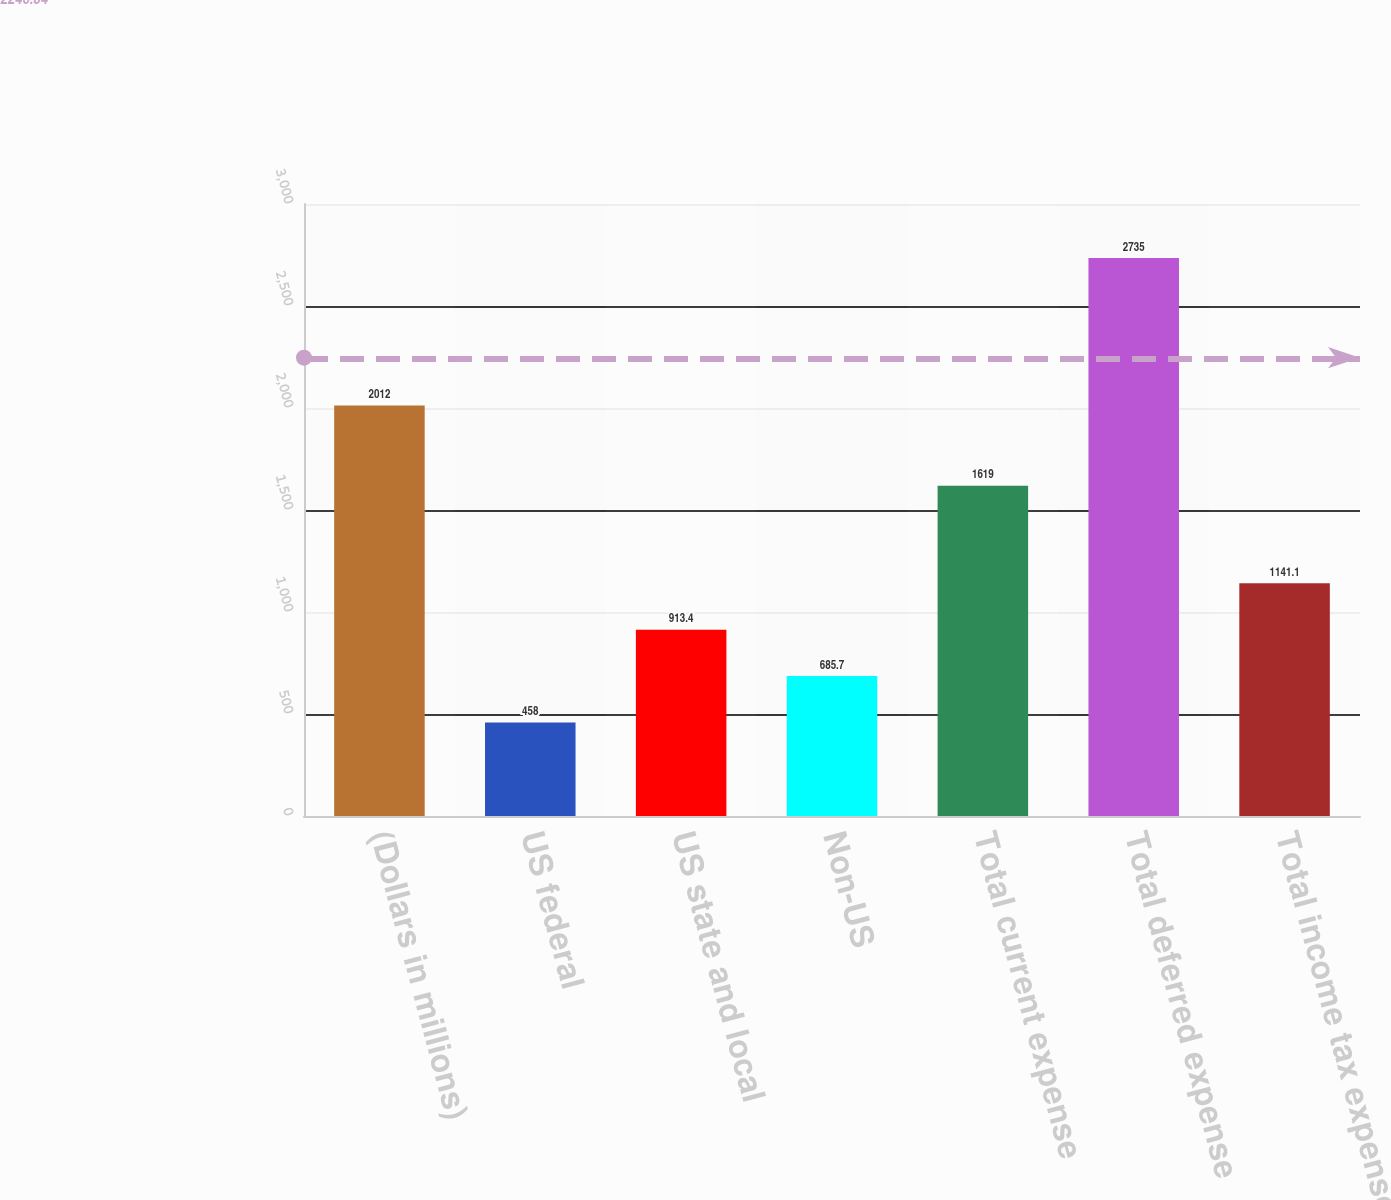<chart> <loc_0><loc_0><loc_500><loc_500><bar_chart><fcel>(Dollars in millions)<fcel>US federal<fcel>US state and local<fcel>Non-US<fcel>Total current expense<fcel>Total deferred expense<fcel>Total income tax expense<nl><fcel>2012<fcel>458<fcel>913.4<fcel>685.7<fcel>1619<fcel>2735<fcel>1141.1<nl></chart> 